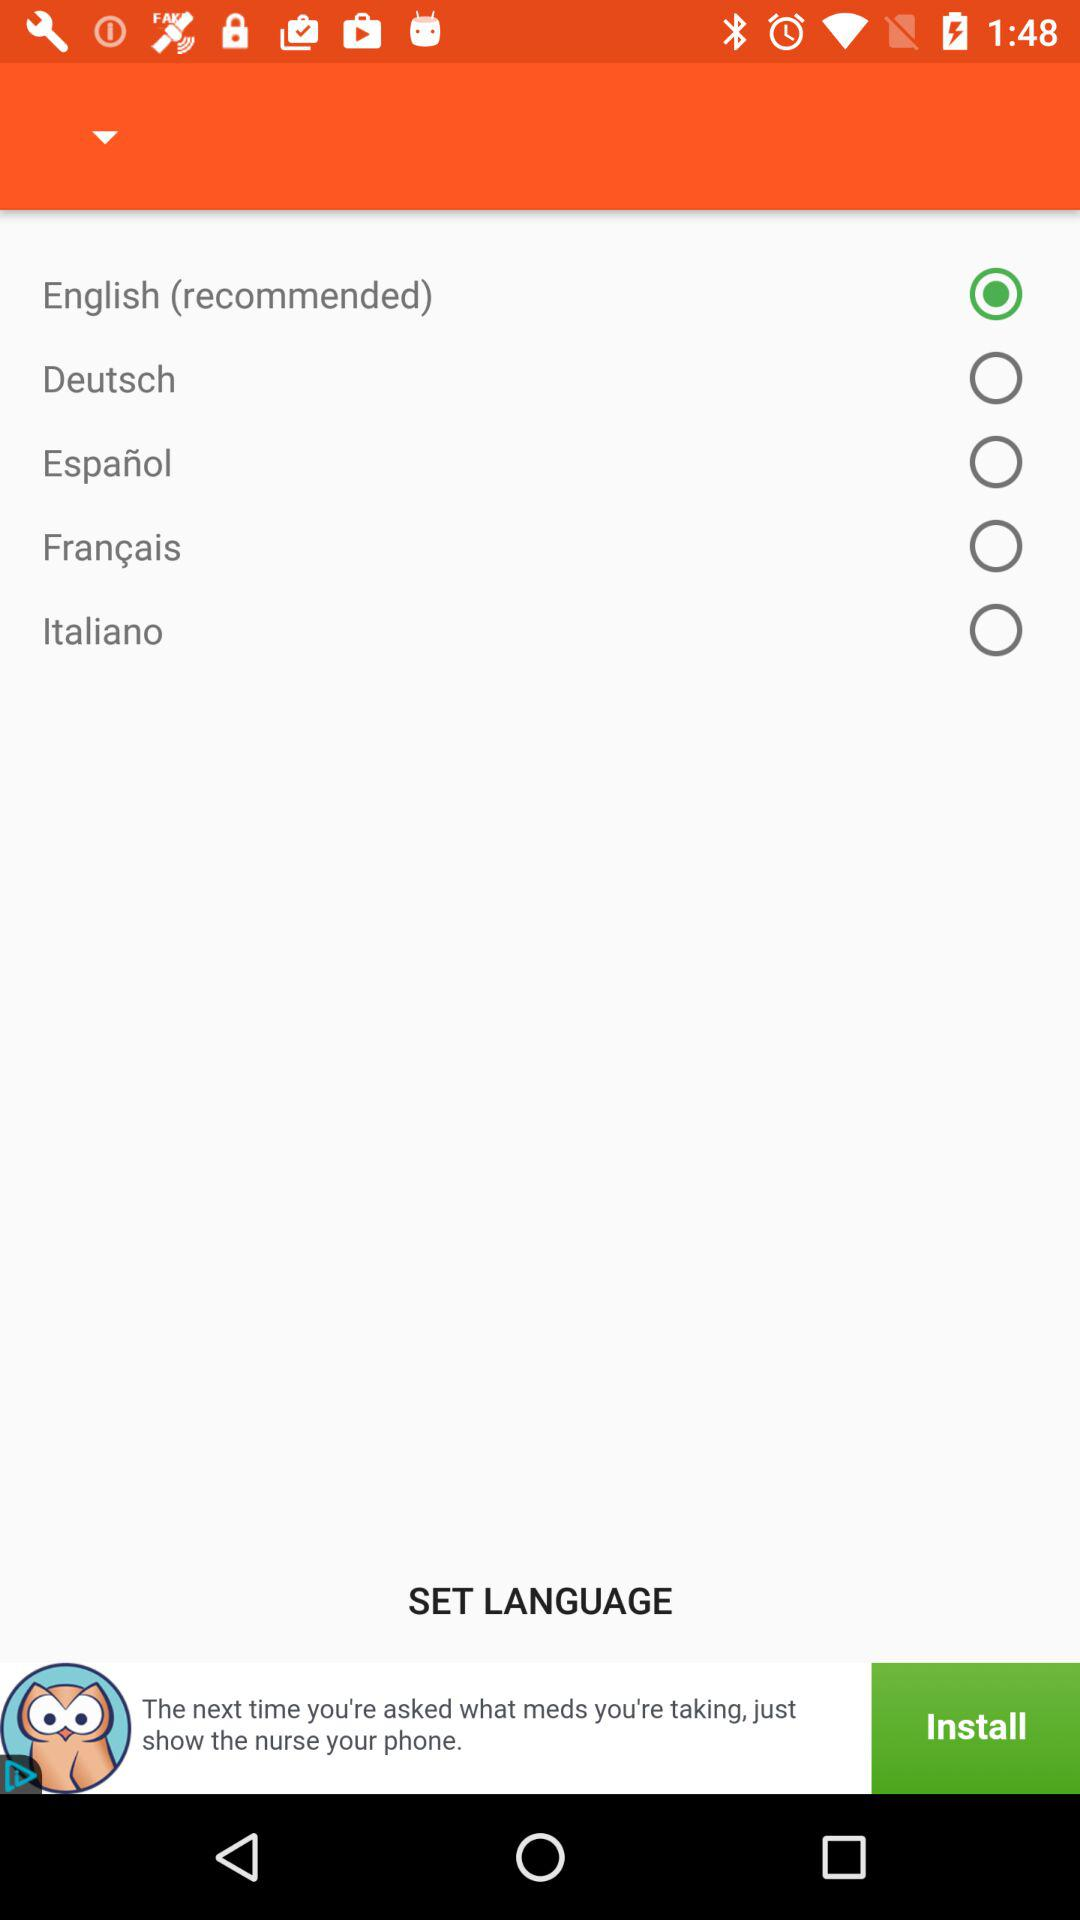What is the selected option? The selected option is "English (recommended)". 